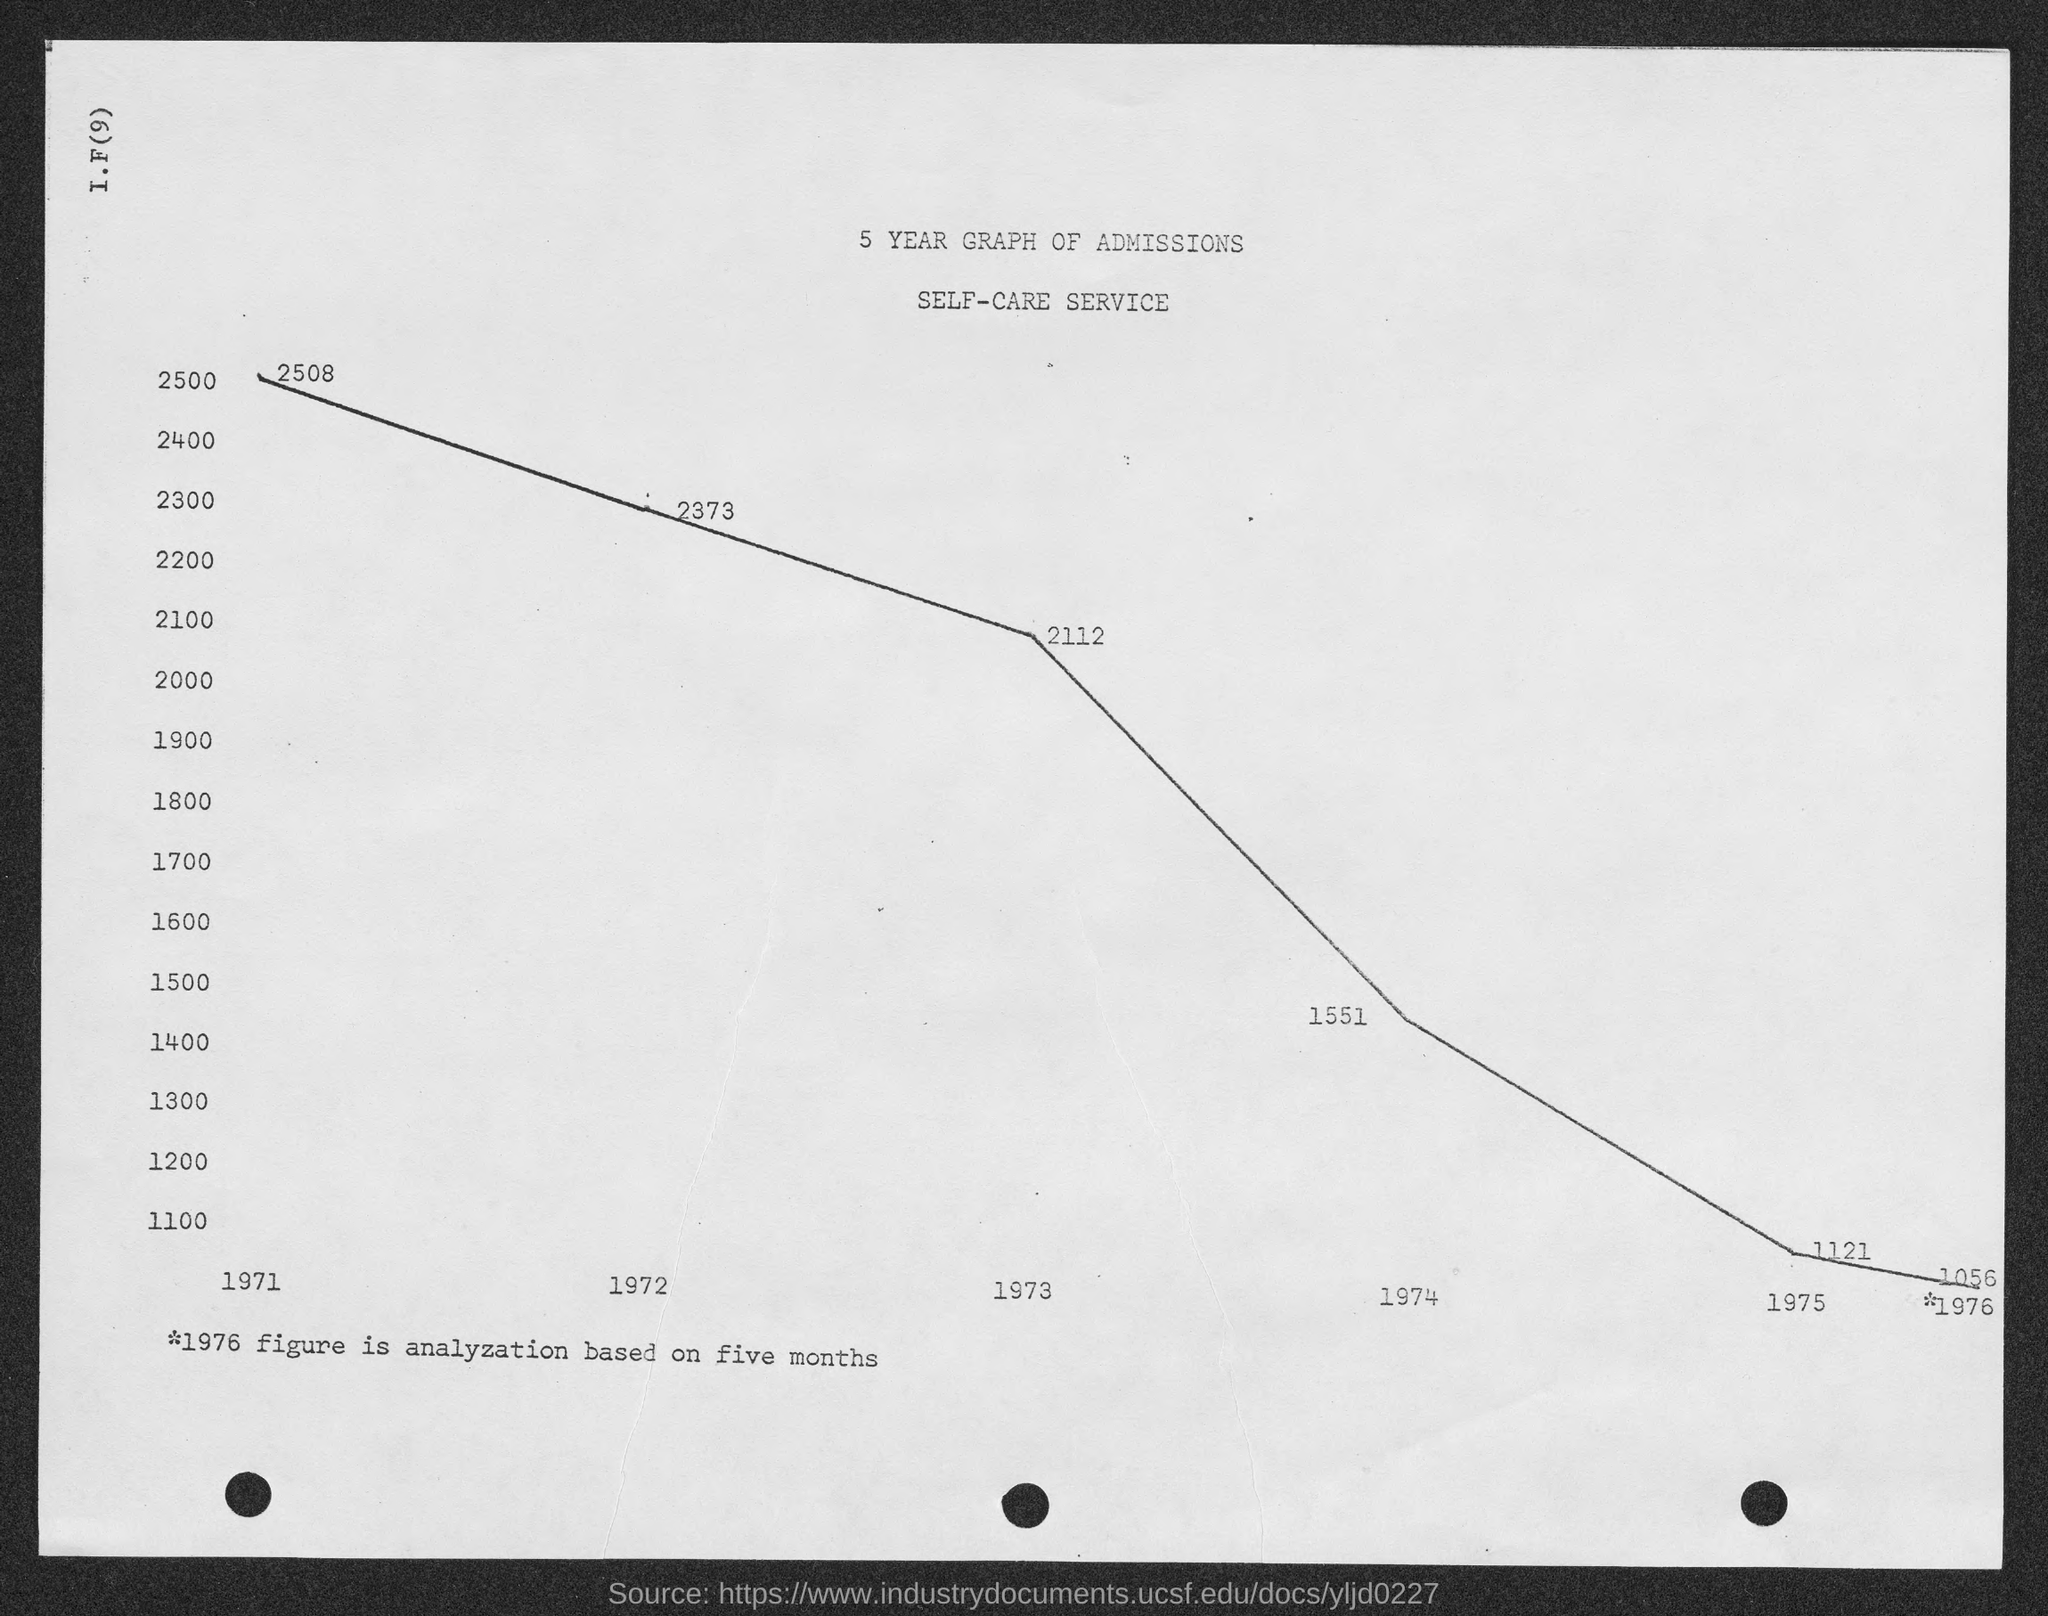What is the value of admissions for the year 1971 as shown in the given page ?
Provide a short and direct response. 2508. What is the value of admissions for the year 1972 as shown in the given page ?
Give a very brief answer. 2373. What is the value of admissions for the year 1973 as shown in the given page ?
Provide a short and direct response. 2112. What is the value of admissions for the year 1974 as shown in the given page ?
Give a very brief answer. 1551. What is the value of admissions for the year 1975  as shown in the given page ?
Your answer should be compact. 1121. 